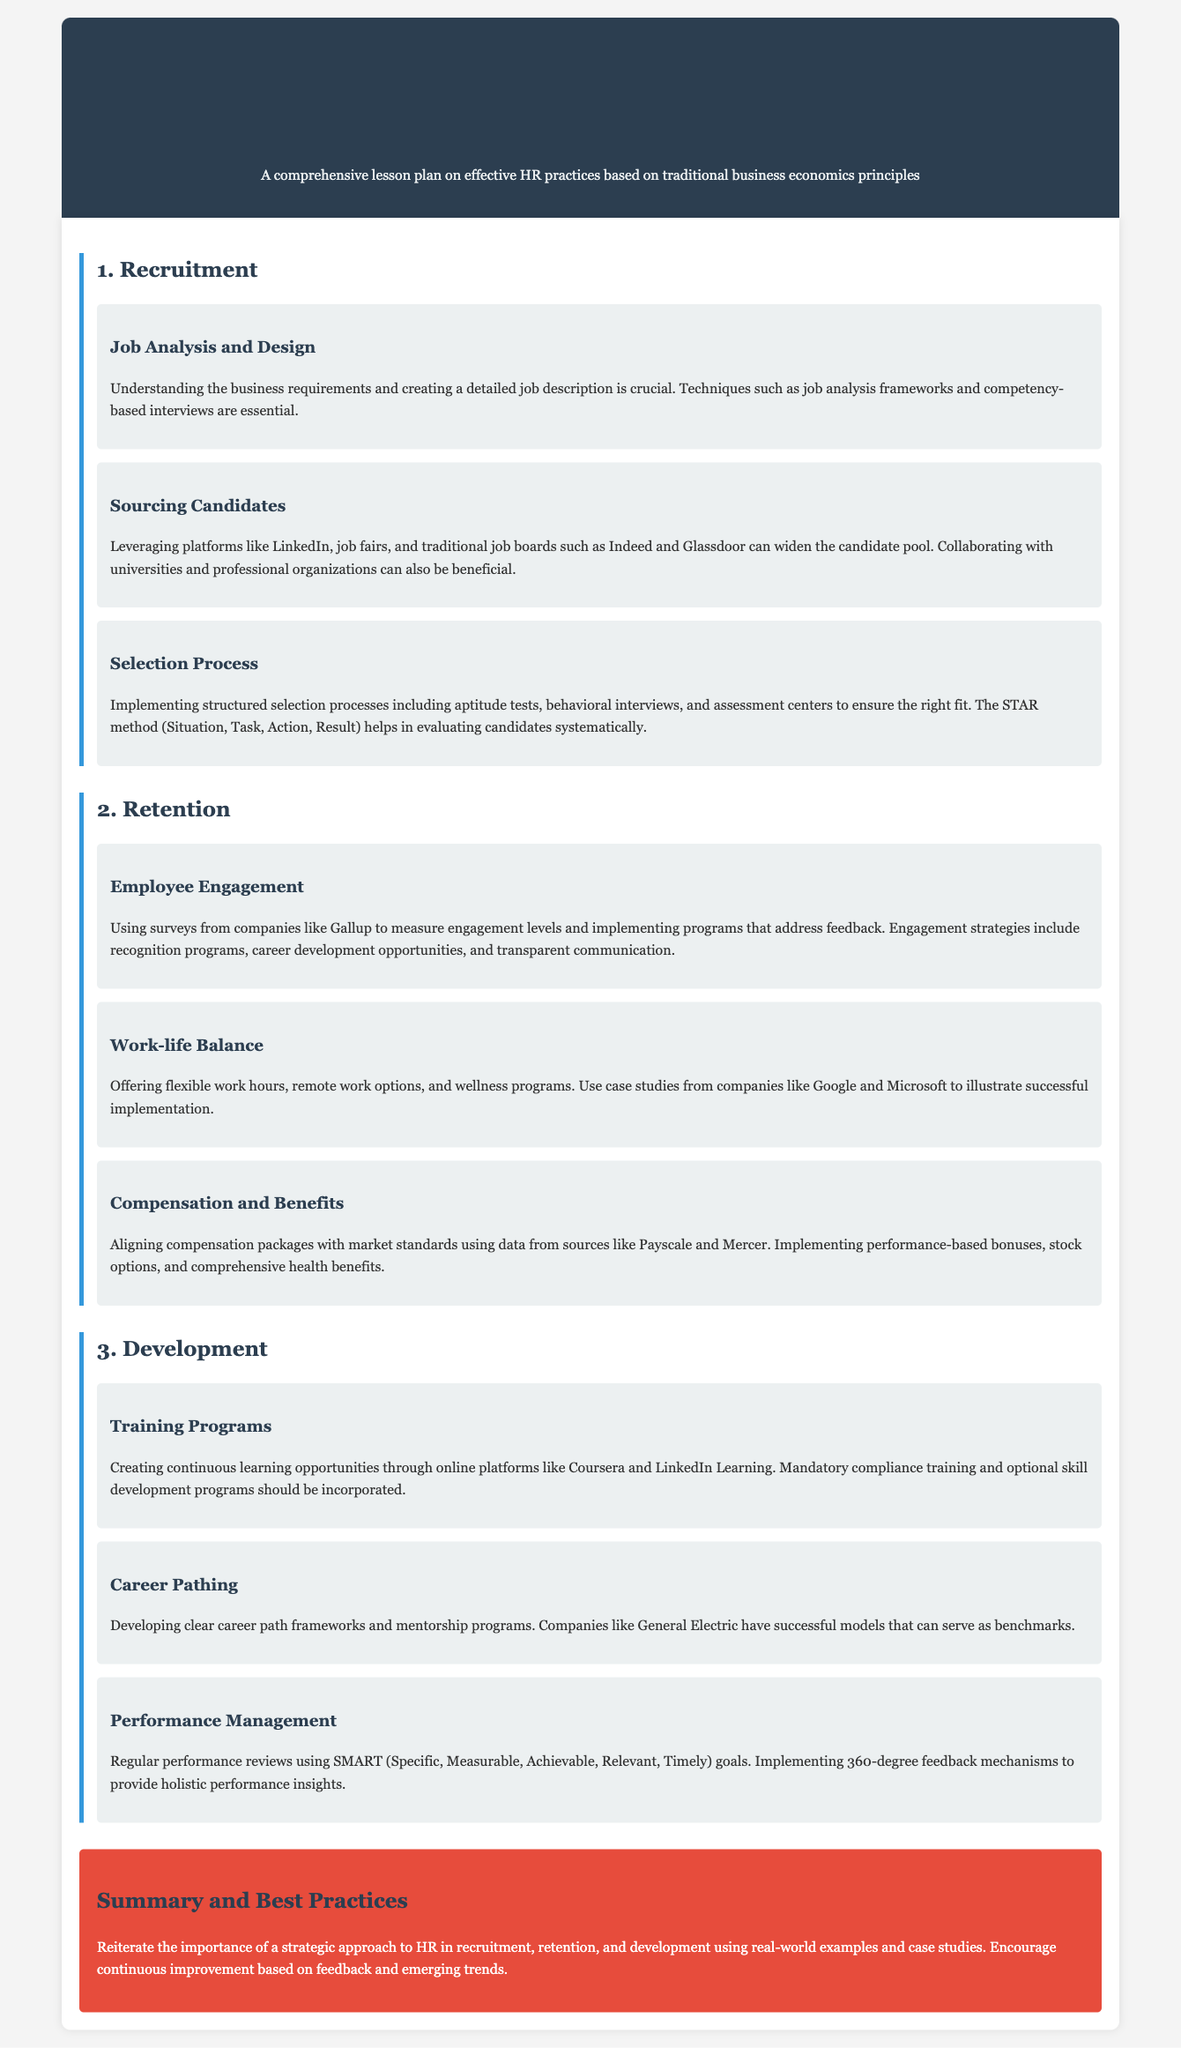What is the title of the lesson plan? The title is displayed prominently at the top of the document, highlighting the HR management focus.
Answer: Human Resource Management: Recruitment, Retention, and Development What technique is essential for job analysis? The document mentions job analysis frameworks as crucial techniques for understanding business requirements.
Answer: Job analysis frameworks Which platforms are suggested for sourcing candidates? The document lists various platforms for candidate sourcing, including LinkedIn and job boards.
Answer: LinkedIn, Indeed, Glassdoor What method helps evaluate candidates systematically? The STAR method is specifically mentioned in the selection process subsection as a way to assess candidates.
Answer: STAR method What is a key strategy for employee engagement? The document suggests using engagement surveys to measure levels and implement feedback programs.
Answer: Engagement surveys What work opportunity is highlighted for retention? Offering flexible work hours is pointed out as a method to enhance work-life balance for employees.
Answer: Flexible work hours Which online platforms are recommended for training programs? The lesson plan recommends Coursera and LinkedIn Learning for creating continuous learning opportunities.
Answer: Coursera, LinkedIn Learning What type of feedback mechanism is discussed in performance management? The document explains that implementing 360-degree feedback mechanisms is crucial for performance evaluations.
Answer: 360-degree feedback What goal-setting framework is mentioned for performance reviews? The SMART framework is specifically referenced in the performance management section of the document.
Answer: SMART What is emphasized in the summary of best practices? The conclusion of the document stresses the importance of a strategic approach to HR in recruitment, retention, and development.
Answer: Strategic approach to HR 